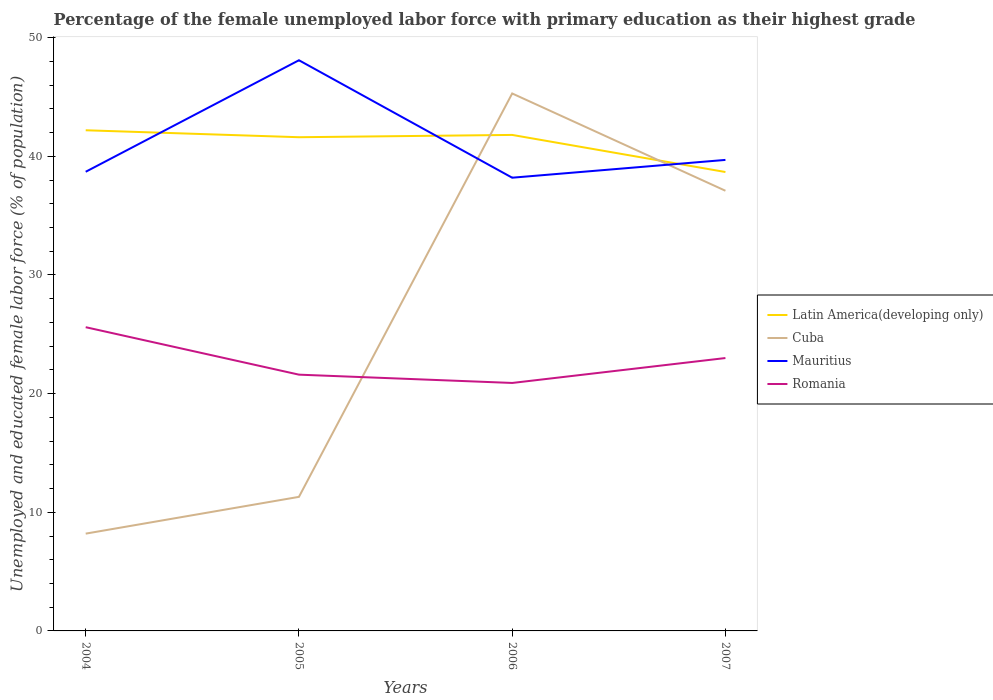Across all years, what is the maximum percentage of the unemployed female labor force with primary education in Romania?
Offer a very short reply. 20.9. What is the total percentage of the unemployed female labor force with primary education in Mauritius in the graph?
Your answer should be compact. -1.5. What is the difference between the highest and the second highest percentage of the unemployed female labor force with primary education in Mauritius?
Offer a very short reply. 9.9. What is the difference between the highest and the lowest percentage of the unemployed female labor force with primary education in Latin America(developing only)?
Give a very brief answer. 3. Is the percentage of the unemployed female labor force with primary education in Cuba strictly greater than the percentage of the unemployed female labor force with primary education in Romania over the years?
Offer a terse response. No. What is the difference between two consecutive major ticks on the Y-axis?
Offer a terse response. 10. Are the values on the major ticks of Y-axis written in scientific E-notation?
Offer a very short reply. No. Does the graph contain any zero values?
Your response must be concise. No. Does the graph contain grids?
Your response must be concise. No. Where does the legend appear in the graph?
Keep it short and to the point. Center right. How are the legend labels stacked?
Provide a short and direct response. Vertical. What is the title of the graph?
Your response must be concise. Percentage of the female unemployed labor force with primary education as their highest grade. What is the label or title of the X-axis?
Offer a terse response. Years. What is the label or title of the Y-axis?
Give a very brief answer. Unemployed and educated female labor force (% of population). What is the Unemployed and educated female labor force (% of population) in Latin America(developing only) in 2004?
Offer a very short reply. 42.2. What is the Unemployed and educated female labor force (% of population) in Cuba in 2004?
Provide a succinct answer. 8.2. What is the Unemployed and educated female labor force (% of population) of Mauritius in 2004?
Your answer should be compact. 38.7. What is the Unemployed and educated female labor force (% of population) of Romania in 2004?
Offer a terse response. 25.6. What is the Unemployed and educated female labor force (% of population) in Latin America(developing only) in 2005?
Keep it short and to the point. 41.61. What is the Unemployed and educated female labor force (% of population) in Cuba in 2005?
Your answer should be very brief. 11.3. What is the Unemployed and educated female labor force (% of population) of Mauritius in 2005?
Your answer should be very brief. 48.1. What is the Unemployed and educated female labor force (% of population) in Romania in 2005?
Make the answer very short. 21.6. What is the Unemployed and educated female labor force (% of population) in Latin America(developing only) in 2006?
Give a very brief answer. 41.81. What is the Unemployed and educated female labor force (% of population) of Cuba in 2006?
Your response must be concise. 45.3. What is the Unemployed and educated female labor force (% of population) of Mauritius in 2006?
Make the answer very short. 38.2. What is the Unemployed and educated female labor force (% of population) of Romania in 2006?
Your response must be concise. 20.9. What is the Unemployed and educated female labor force (% of population) of Latin America(developing only) in 2007?
Your response must be concise. 38.68. What is the Unemployed and educated female labor force (% of population) in Cuba in 2007?
Make the answer very short. 37.1. What is the Unemployed and educated female labor force (% of population) in Mauritius in 2007?
Offer a very short reply. 39.7. What is the Unemployed and educated female labor force (% of population) of Romania in 2007?
Offer a terse response. 23. Across all years, what is the maximum Unemployed and educated female labor force (% of population) of Latin America(developing only)?
Your response must be concise. 42.2. Across all years, what is the maximum Unemployed and educated female labor force (% of population) of Cuba?
Your answer should be compact. 45.3. Across all years, what is the maximum Unemployed and educated female labor force (% of population) in Mauritius?
Make the answer very short. 48.1. Across all years, what is the maximum Unemployed and educated female labor force (% of population) in Romania?
Offer a terse response. 25.6. Across all years, what is the minimum Unemployed and educated female labor force (% of population) of Latin America(developing only)?
Your response must be concise. 38.68. Across all years, what is the minimum Unemployed and educated female labor force (% of population) of Cuba?
Offer a terse response. 8.2. Across all years, what is the minimum Unemployed and educated female labor force (% of population) of Mauritius?
Keep it short and to the point. 38.2. Across all years, what is the minimum Unemployed and educated female labor force (% of population) of Romania?
Give a very brief answer. 20.9. What is the total Unemployed and educated female labor force (% of population) of Latin America(developing only) in the graph?
Your answer should be very brief. 164.3. What is the total Unemployed and educated female labor force (% of population) of Cuba in the graph?
Keep it short and to the point. 101.9. What is the total Unemployed and educated female labor force (% of population) in Mauritius in the graph?
Your response must be concise. 164.7. What is the total Unemployed and educated female labor force (% of population) of Romania in the graph?
Provide a short and direct response. 91.1. What is the difference between the Unemployed and educated female labor force (% of population) of Latin America(developing only) in 2004 and that in 2005?
Your response must be concise. 0.59. What is the difference between the Unemployed and educated female labor force (% of population) in Cuba in 2004 and that in 2005?
Provide a succinct answer. -3.1. What is the difference between the Unemployed and educated female labor force (% of population) of Mauritius in 2004 and that in 2005?
Make the answer very short. -9.4. What is the difference between the Unemployed and educated female labor force (% of population) in Latin America(developing only) in 2004 and that in 2006?
Your answer should be compact. 0.39. What is the difference between the Unemployed and educated female labor force (% of population) in Cuba in 2004 and that in 2006?
Offer a very short reply. -37.1. What is the difference between the Unemployed and educated female labor force (% of population) in Latin America(developing only) in 2004 and that in 2007?
Keep it short and to the point. 3.52. What is the difference between the Unemployed and educated female labor force (% of population) of Cuba in 2004 and that in 2007?
Make the answer very short. -28.9. What is the difference between the Unemployed and educated female labor force (% of population) in Latin America(developing only) in 2005 and that in 2006?
Your response must be concise. -0.19. What is the difference between the Unemployed and educated female labor force (% of population) of Cuba in 2005 and that in 2006?
Give a very brief answer. -34. What is the difference between the Unemployed and educated female labor force (% of population) of Latin America(developing only) in 2005 and that in 2007?
Your answer should be very brief. 2.93. What is the difference between the Unemployed and educated female labor force (% of population) of Cuba in 2005 and that in 2007?
Your answer should be compact. -25.8. What is the difference between the Unemployed and educated female labor force (% of population) of Latin America(developing only) in 2006 and that in 2007?
Ensure brevity in your answer.  3.13. What is the difference between the Unemployed and educated female labor force (% of population) in Latin America(developing only) in 2004 and the Unemployed and educated female labor force (% of population) in Cuba in 2005?
Offer a very short reply. 30.9. What is the difference between the Unemployed and educated female labor force (% of population) of Latin America(developing only) in 2004 and the Unemployed and educated female labor force (% of population) of Mauritius in 2005?
Provide a short and direct response. -5.9. What is the difference between the Unemployed and educated female labor force (% of population) of Latin America(developing only) in 2004 and the Unemployed and educated female labor force (% of population) of Romania in 2005?
Give a very brief answer. 20.6. What is the difference between the Unemployed and educated female labor force (% of population) of Cuba in 2004 and the Unemployed and educated female labor force (% of population) of Mauritius in 2005?
Your answer should be very brief. -39.9. What is the difference between the Unemployed and educated female labor force (% of population) of Mauritius in 2004 and the Unemployed and educated female labor force (% of population) of Romania in 2005?
Your answer should be compact. 17.1. What is the difference between the Unemployed and educated female labor force (% of population) in Latin America(developing only) in 2004 and the Unemployed and educated female labor force (% of population) in Cuba in 2006?
Provide a short and direct response. -3.1. What is the difference between the Unemployed and educated female labor force (% of population) of Latin America(developing only) in 2004 and the Unemployed and educated female labor force (% of population) of Mauritius in 2006?
Your response must be concise. 4. What is the difference between the Unemployed and educated female labor force (% of population) of Latin America(developing only) in 2004 and the Unemployed and educated female labor force (% of population) of Romania in 2006?
Make the answer very short. 21.3. What is the difference between the Unemployed and educated female labor force (% of population) of Cuba in 2004 and the Unemployed and educated female labor force (% of population) of Romania in 2006?
Your answer should be very brief. -12.7. What is the difference between the Unemployed and educated female labor force (% of population) in Latin America(developing only) in 2004 and the Unemployed and educated female labor force (% of population) in Cuba in 2007?
Your answer should be compact. 5.1. What is the difference between the Unemployed and educated female labor force (% of population) in Latin America(developing only) in 2004 and the Unemployed and educated female labor force (% of population) in Mauritius in 2007?
Offer a terse response. 2.5. What is the difference between the Unemployed and educated female labor force (% of population) of Latin America(developing only) in 2004 and the Unemployed and educated female labor force (% of population) of Romania in 2007?
Your answer should be compact. 19.2. What is the difference between the Unemployed and educated female labor force (% of population) in Cuba in 2004 and the Unemployed and educated female labor force (% of population) in Mauritius in 2007?
Give a very brief answer. -31.5. What is the difference between the Unemployed and educated female labor force (% of population) of Cuba in 2004 and the Unemployed and educated female labor force (% of population) of Romania in 2007?
Provide a short and direct response. -14.8. What is the difference between the Unemployed and educated female labor force (% of population) of Mauritius in 2004 and the Unemployed and educated female labor force (% of population) of Romania in 2007?
Your answer should be compact. 15.7. What is the difference between the Unemployed and educated female labor force (% of population) of Latin America(developing only) in 2005 and the Unemployed and educated female labor force (% of population) of Cuba in 2006?
Provide a succinct answer. -3.69. What is the difference between the Unemployed and educated female labor force (% of population) in Latin America(developing only) in 2005 and the Unemployed and educated female labor force (% of population) in Mauritius in 2006?
Offer a very short reply. 3.41. What is the difference between the Unemployed and educated female labor force (% of population) of Latin America(developing only) in 2005 and the Unemployed and educated female labor force (% of population) of Romania in 2006?
Make the answer very short. 20.71. What is the difference between the Unemployed and educated female labor force (% of population) in Cuba in 2005 and the Unemployed and educated female labor force (% of population) in Mauritius in 2006?
Offer a very short reply. -26.9. What is the difference between the Unemployed and educated female labor force (% of population) of Mauritius in 2005 and the Unemployed and educated female labor force (% of population) of Romania in 2006?
Give a very brief answer. 27.2. What is the difference between the Unemployed and educated female labor force (% of population) in Latin America(developing only) in 2005 and the Unemployed and educated female labor force (% of population) in Cuba in 2007?
Give a very brief answer. 4.51. What is the difference between the Unemployed and educated female labor force (% of population) in Latin America(developing only) in 2005 and the Unemployed and educated female labor force (% of population) in Mauritius in 2007?
Ensure brevity in your answer.  1.91. What is the difference between the Unemployed and educated female labor force (% of population) of Latin America(developing only) in 2005 and the Unemployed and educated female labor force (% of population) of Romania in 2007?
Make the answer very short. 18.61. What is the difference between the Unemployed and educated female labor force (% of population) of Cuba in 2005 and the Unemployed and educated female labor force (% of population) of Mauritius in 2007?
Your answer should be compact. -28.4. What is the difference between the Unemployed and educated female labor force (% of population) in Cuba in 2005 and the Unemployed and educated female labor force (% of population) in Romania in 2007?
Provide a short and direct response. -11.7. What is the difference between the Unemployed and educated female labor force (% of population) in Mauritius in 2005 and the Unemployed and educated female labor force (% of population) in Romania in 2007?
Provide a succinct answer. 25.1. What is the difference between the Unemployed and educated female labor force (% of population) of Latin America(developing only) in 2006 and the Unemployed and educated female labor force (% of population) of Cuba in 2007?
Your response must be concise. 4.71. What is the difference between the Unemployed and educated female labor force (% of population) of Latin America(developing only) in 2006 and the Unemployed and educated female labor force (% of population) of Mauritius in 2007?
Your answer should be compact. 2.11. What is the difference between the Unemployed and educated female labor force (% of population) of Latin America(developing only) in 2006 and the Unemployed and educated female labor force (% of population) of Romania in 2007?
Make the answer very short. 18.81. What is the difference between the Unemployed and educated female labor force (% of population) of Cuba in 2006 and the Unemployed and educated female labor force (% of population) of Romania in 2007?
Offer a terse response. 22.3. What is the average Unemployed and educated female labor force (% of population) of Latin America(developing only) per year?
Your answer should be compact. 41.07. What is the average Unemployed and educated female labor force (% of population) of Cuba per year?
Make the answer very short. 25.48. What is the average Unemployed and educated female labor force (% of population) of Mauritius per year?
Give a very brief answer. 41.17. What is the average Unemployed and educated female labor force (% of population) of Romania per year?
Your answer should be very brief. 22.77. In the year 2004, what is the difference between the Unemployed and educated female labor force (% of population) in Latin America(developing only) and Unemployed and educated female labor force (% of population) in Cuba?
Ensure brevity in your answer.  34. In the year 2004, what is the difference between the Unemployed and educated female labor force (% of population) in Latin America(developing only) and Unemployed and educated female labor force (% of population) in Mauritius?
Provide a succinct answer. 3.5. In the year 2004, what is the difference between the Unemployed and educated female labor force (% of population) of Latin America(developing only) and Unemployed and educated female labor force (% of population) of Romania?
Provide a short and direct response. 16.6. In the year 2004, what is the difference between the Unemployed and educated female labor force (% of population) of Cuba and Unemployed and educated female labor force (% of population) of Mauritius?
Make the answer very short. -30.5. In the year 2004, what is the difference between the Unemployed and educated female labor force (% of population) of Cuba and Unemployed and educated female labor force (% of population) of Romania?
Your answer should be very brief. -17.4. In the year 2005, what is the difference between the Unemployed and educated female labor force (% of population) in Latin America(developing only) and Unemployed and educated female labor force (% of population) in Cuba?
Your response must be concise. 30.31. In the year 2005, what is the difference between the Unemployed and educated female labor force (% of population) of Latin America(developing only) and Unemployed and educated female labor force (% of population) of Mauritius?
Your answer should be compact. -6.49. In the year 2005, what is the difference between the Unemployed and educated female labor force (% of population) of Latin America(developing only) and Unemployed and educated female labor force (% of population) of Romania?
Your answer should be compact. 20.01. In the year 2005, what is the difference between the Unemployed and educated female labor force (% of population) in Cuba and Unemployed and educated female labor force (% of population) in Mauritius?
Provide a short and direct response. -36.8. In the year 2005, what is the difference between the Unemployed and educated female labor force (% of population) of Cuba and Unemployed and educated female labor force (% of population) of Romania?
Keep it short and to the point. -10.3. In the year 2006, what is the difference between the Unemployed and educated female labor force (% of population) of Latin America(developing only) and Unemployed and educated female labor force (% of population) of Cuba?
Make the answer very short. -3.49. In the year 2006, what is the difference between the Unemployed and educated female labor force (% of population) in Latin America(developing only) and Unemployed and educated female labor force (% of population) in Mauritius?
Give a very brief answer. 3.61. In the year 2006, what is the difference between the Unemployed and educated female labor force (% of population) in Latin America(developing only) and Unemployed and educated female labor force (% of population) in Romania?
Your answer should be compact. 20.91. In the year 2006, what is the difference between the Unemployed and educated female labor force (% of population) in Cuba and Unemployed and educated female labor force (% of population) in Mauritius?
Ensure brevity in your answer.  7.1. In the year 2006, what is the difference between the Unemployed and educated female labor force (% of population) in Cuba and Unemployed and educated female labor force (% of population) in Romania?
Provide a succinct answer. 24.4. In the year 2006, what is the difference between the Unemployed and educated female labor force (% of population) of Mauritius and Unemployed and educated female labor force (% of population) of Romania?
Your answer should be very brief. 17.3. In the year 2007, what is the difference between the Unemployed and educated female labor force (% of population) in Latin America(developing only) and Unemployed and educated female labor force (% of population) in Cuba?
Ensure brevity in your answer.  1.58. In the year 2007, what is the difference between the Unemployed and educated female labor force (% of population) in Latin America(developing only) and Unemployed and educated female labor force (% of population) in Mauritius?
Your answer should be very brief. -1.02. In the year 2007, what is the difference between the Unemployed and educated female labor force (% of population) in Latin America(developing only) and Unemployed and educated female labor force (% of population) in Romania?
Ensure brevity in your answer.  15.68. In the year 2007, what is the difference between the Unemployed and educated female labor force (% of population) of Cuba and Unemployed and educated female labor force (% of population) of Romania?
Provide a succinct answer. 14.1. In the year 2007, what is the difference between the Unemployed and educated female labor force (% of population) in Mauritius and Unemployed and educated female labor force (% of population) in Romania?
Make the answer very short. 16.7. What is the ratio of the Unemployed and educated female labor force (% of population) of Latin America(developing only) in 2004 to that in 2005?
Keep it short and to the point. 1.01. What is the ratio of the Unemployed and educated female labor force (% of population) in Cuba in 2004 to that in 2005?
Your response must be concise. 0.73. What is the ratio of the Unemployed and educated female labor force (% of population) in Mauritius in 2004 to that in 2005?
Keep it short and to the point. 0.8. What is the ratio of the Unemployed and educated female labor force (% of population) in Romania in 2004 to that in 2005?
Make the answer very short. 1.19. What is the ratio of the Unemployed and educated female labor force (% of population) in Latin America(developing only) in 2004 to that in 2006?
Give a very brief answer. 1.01. What is the ratio of the Unemployed and educated female labor force (% of population) of Cuba in 2004 to that in 2006?
Give a very brief answer. 0.18. What is the ratio of the Unemployed and educated female labor force (% of population) in Mauritius in 2004 to that in 2006?
Provide a short and direct response. 1.01. What is the ratio of the Unemployed and educated female labor force (% of population) of Romania in 2004 to that in 2006?
Offer a terse response. 1.22. What is the ratio of the Unemployed and educated female labor force (% of population) of Latin America(developing only) in 2004 to that in 2007?
Your answer should be compact. 1.09. What is the ratio of the Unemployed and educated female labor force (% of population) in Cuba in 2004 to that in 2007?
Your answer should be compact. 0.22. What is the ratio of the Unemployed and educated female labor force (% of population) of Mauritius in 2004 to that in 2007?
Ensure brevity in your answer.  0.97. What is the ratio of the Unemployed and educated female labor force (% of population) in Romania in 2004 to that in 2007?
Provide a succinct answer. 1.11. What is the ratio of the Unemployed and educated female labor force (% of population) in Cuba in 2005 to that in 2006?
Ensure brevity in your answer.  0.25. What is the ratio of the Unemployed and educated female labor force (% of population) of Mauritius in 2005 to that in 2006?
Ensure brevity in your answer.  1.26. What is the ratio of the Unemployed and educated female labor force (% of population) of Romania in 2005 to that in 2006?
Keep it short and to the point. 1.03. What is the ratio of the Unemployed and educated female labor force (% of population) of Latin America(developing only) in 2005 to that in 2007?
Offer a very short reply. 1.08. What is the ratio of the Unemployed and educated female labor force (% of population) of Cuba in 2005 to that in 2007?
Offer a very short reply. 0.3. What is the ratio of the Unemployed and educated female labor force (% of population) of Mauritius in 2005 to that in 2007?
Your answer should be compact. 1.21. What is the ratio of the Unemployed and educated female labor force (% of population) in Romania in 2005 to that in 2007?
Ensure brevity in your answer.  0.94. What is the ratio of the Unemployed and educated female labor force (% of population) in Latin America(developing only) in 2006 to that in 2007?
Your response must be concise. 1.08. What is the ratio of the Unemployed and educated female labor force (% of population) of Cuba in 2006 to that in 2007?
Provide a short and direct response. 1.22. What is the ratio of the Unemployed and educated female labor force (% of population) in Mauritius in 2006 to that in 2007?
Provide a succinct answer. 0.96. What is the ratio of the Unemployed and educated female labor force (% of population) in Romania in 2006 to that in 2007?
Your answer should be compact. 0.91. What is the difference between the highest and the second highest Unemployed and educated female labor force (% of population) of Latin America(developing only)?
Make the answer very short. 0.39. What is the difference between the highest and the second highest Unemployed and educated female labor force (% of population) of Cuba?
Provide a short and direct response. 8.2. What is the difference between the highest and the second highest Unemployed and educated female labor force (% of population) of Mauritius?
Your answer should be compact. 8.4. What is the difference between the highest and the lowest Unemployed and educated female labor force (% of population) of Latin America(developing only)?
Keep it short and to the point. 3.52. What is the difference between the highest and the lowest Unemployed and educated female labor force (% of population) of Cuba?
Give a very brief answer. 37.1. What is the difference between the highest and the lowest Unemployed and educated female labor force (% of population) of Mauritius?
Your response must be concise. 9.9. What is the difference between the highest and the lowest Unemployed and educated female labor force (% of population) in Romania?
Your answer should be compact. 4.7. 